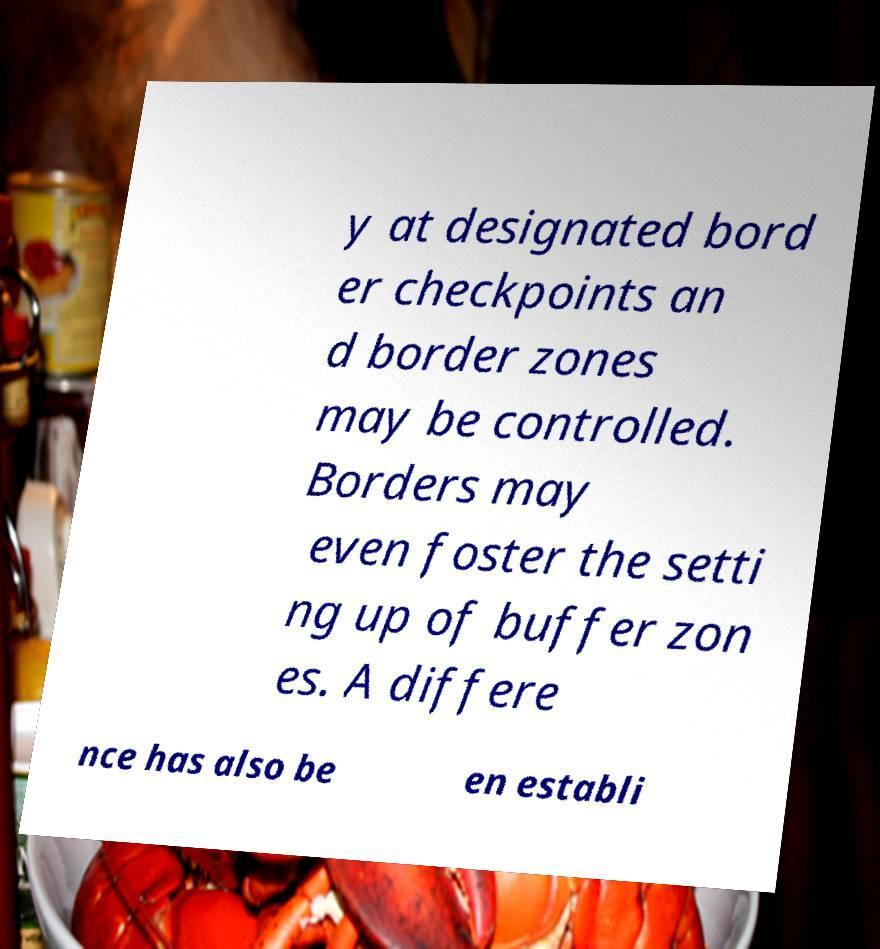There's text embedded in this image that I need extracted. Can you transcribe it verbatim? y at designated bord er checkpoints an d border zones may be controlled. Borders may even foster the setti ng up of buffer zon es. A differe nce has also be en establi 